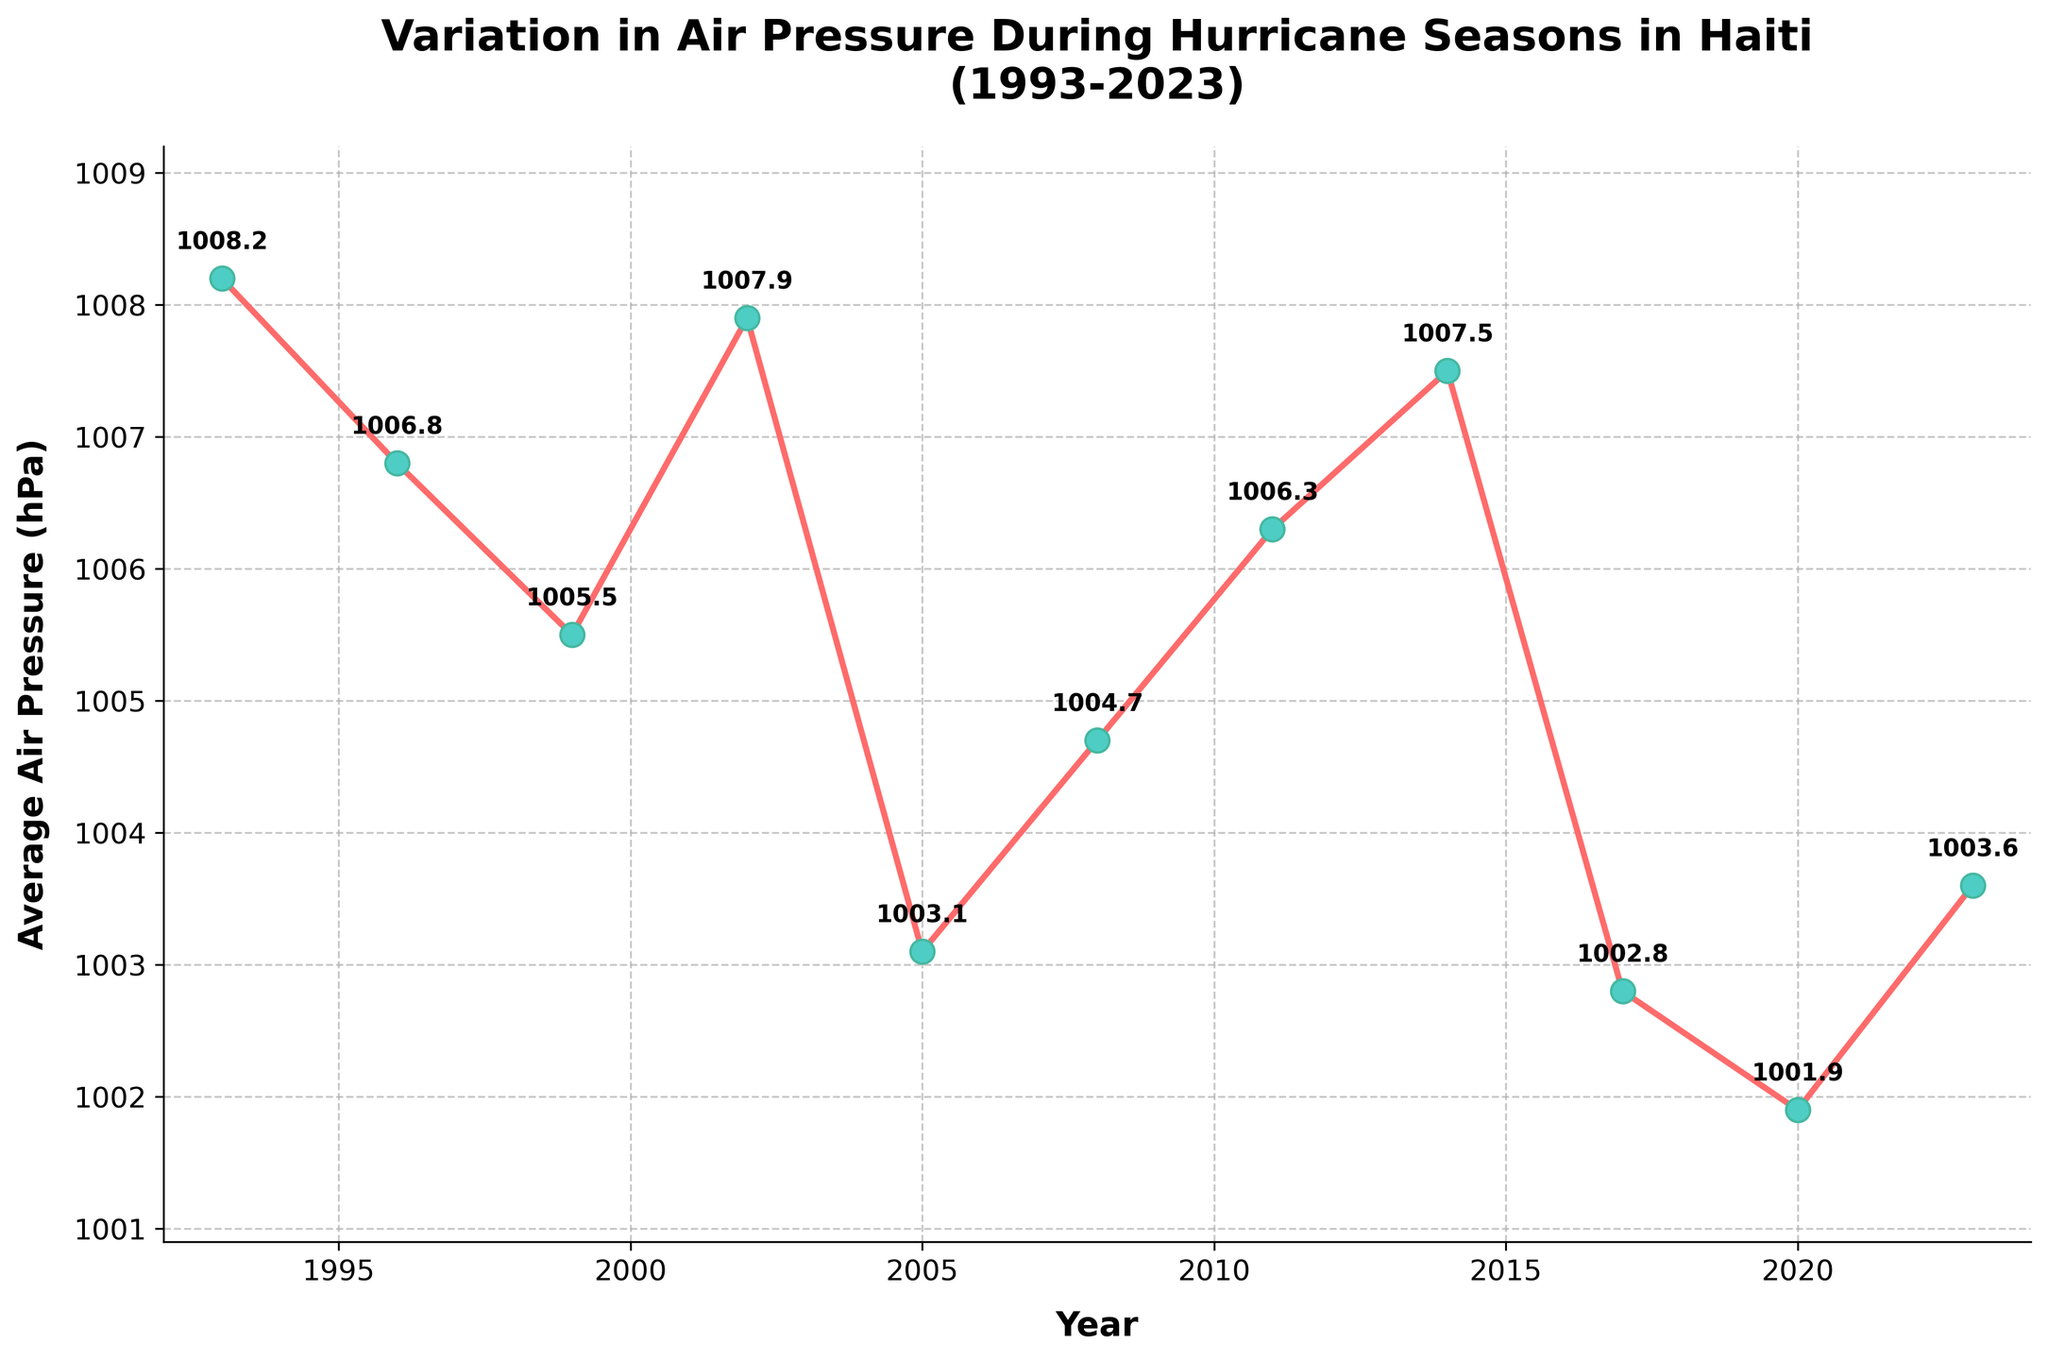What's the lowest average air pressure recorded during the period? The lowest point on the plot corresponds to the year 2020, where the average air pressure is clearly indicated by the smallest y-value.
Answer: 1001.9 hPa Which year saw the highest average air pressure? By observing the highest point on the y-axis, we can identify that the year 1993 recorded the highest average air pressure.
Answer: 1993 How much did the average air pressure decrease from 1993 to 2020? The average air pressure in 1993 was 1008.2 hPa. In 2020, it was 1001.9 hPa. The change is 1008.2 - 1001.9.
Answer: 6.3 hPa In which year did the average air pressure most significantly drop compared to the previous recorded value? By inspecting the differences between successive points, the largest drop is from 2017 (1002.8 hPa) to 2020 (1001.9 hPa).
Answer: 2017 to 2020 What is the average of the three lowest air pressure readings on the plot? The three lowest readings are 1001.9 (2020), 1002.8 (2017), 1003.1 (2005). Average is calculated as (1001.9 + 1002.8 + 1003.1)/3.
Answer: 1002.6 hPa How does the average air pressure in 2005 compare to that in 1996? The plot shows the average air pressure in 2005 is lower than in 1996. Numerical values are 1003.1 hPa for 2005 and 1006.8 hPa for 1996.
Answer: Lower Describe the trend in average air pressure from 2014 to 2023. The plot shows a significant drop from 2014 (1007.5 hPa) to 2017 (1002.8 hPa) and then a slight increase to 2023 (1003.6 hPa).
Answer: Decreasing, then slightly increasing What is the range of the average air pressure readings over the period? The range is the difference between the highest (1008.2 hPa in 1993) and lowest (1001.9 hPa in 2020) points on the plot.
Answer: 6.3 hPa Which year experienced an average air pressure below 1004 hPa but above 1002 hPa? By observing points on the y-axis between 1002 hPa and 1004 hPa, we identify the year 2017.
Answer: 2017 How does the average air pressure in 2002 compare visually to that in 2008? The dot for 2002 appears slightly higher on the y-axis compared to 2008. The numerical values are 1007.9 hPa for 2002 and 1004.7 hPa for 2008.
Answer: Higher 